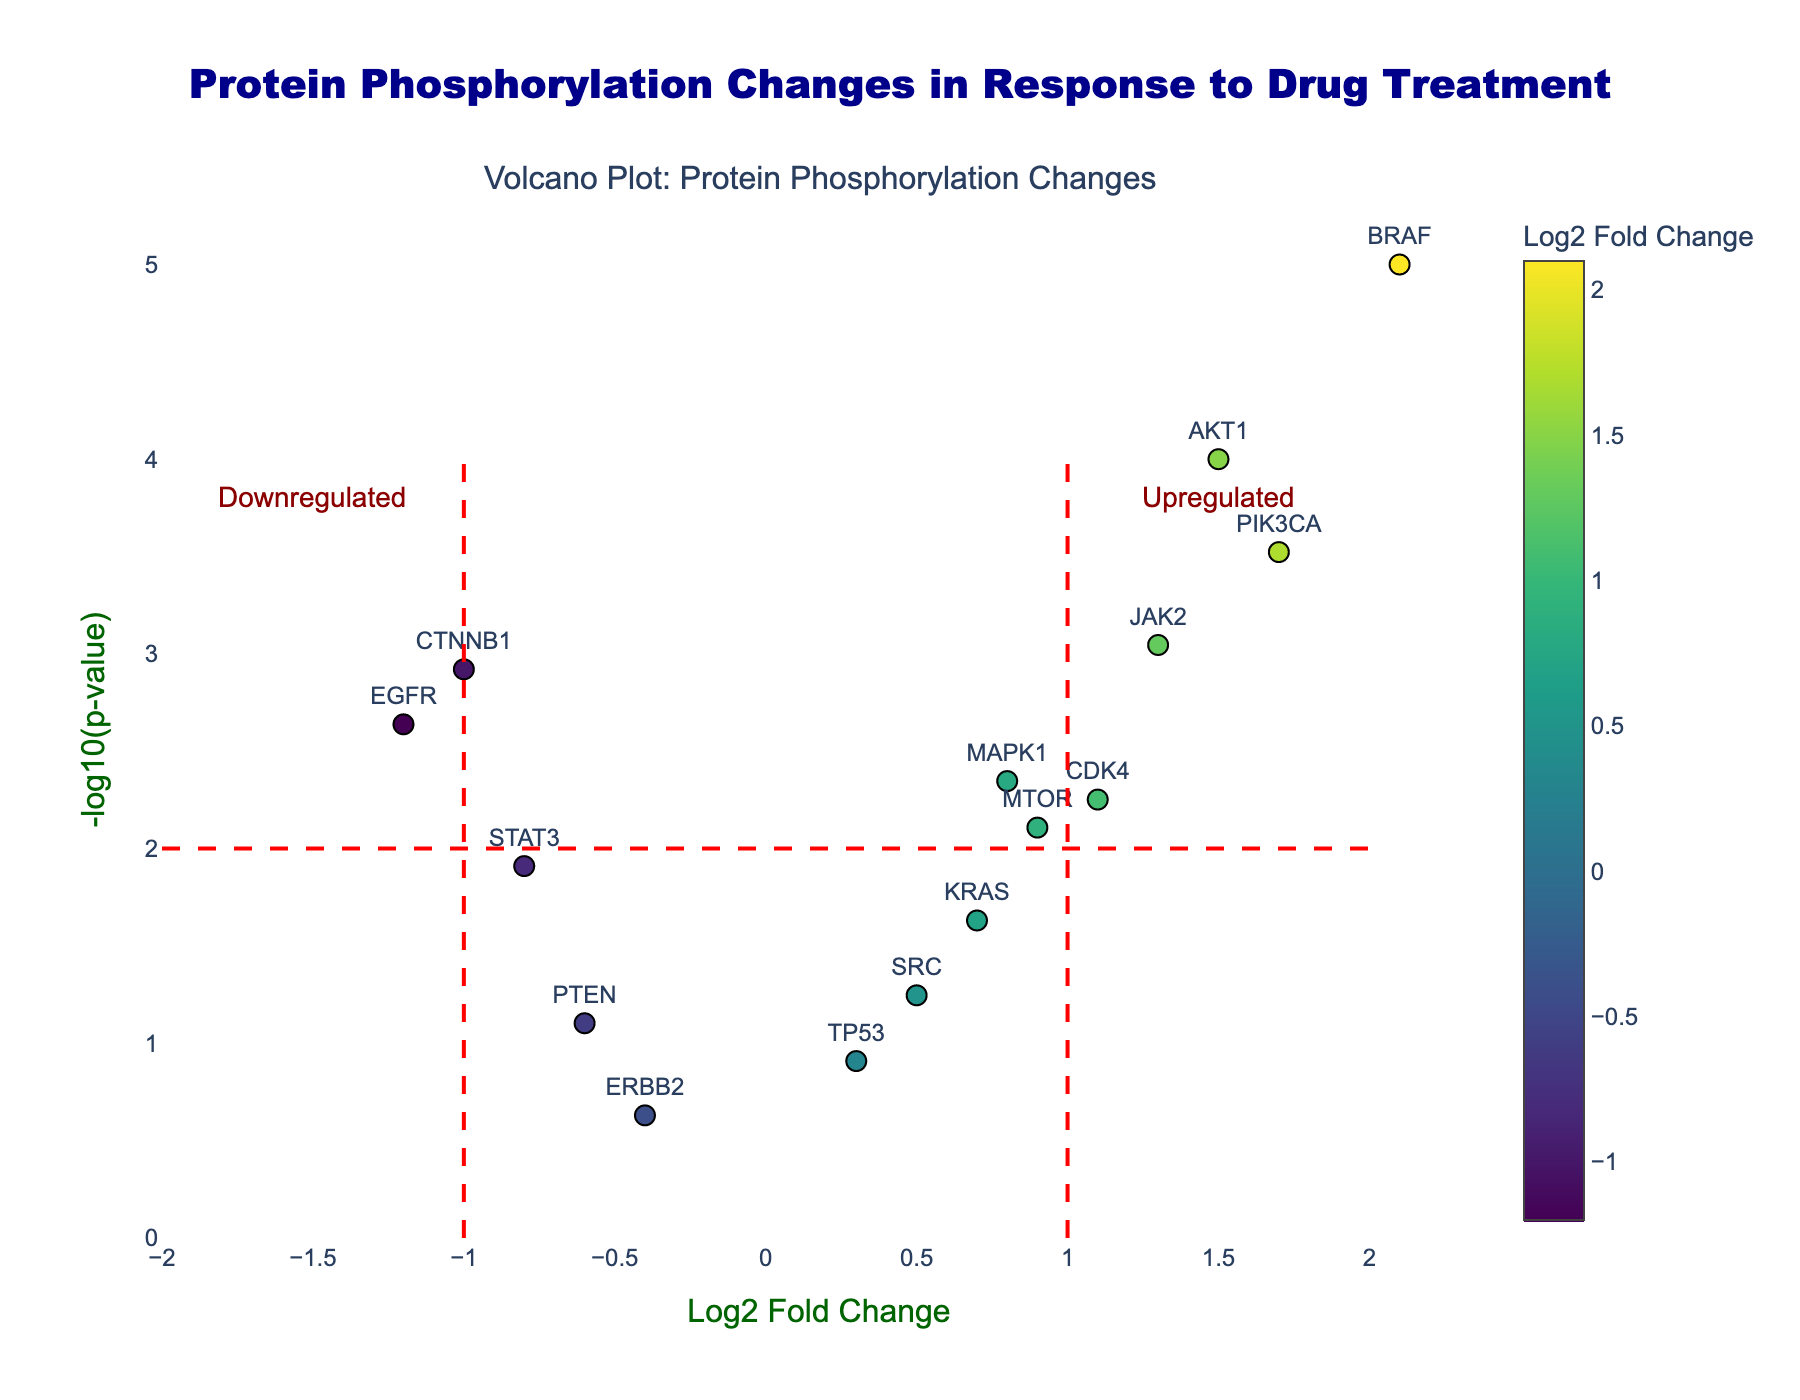What's the title of the figure? Look at the top center of the figure where the title is provided in a large font.
Answer: Protein Phosphorylation Changes in Response to Drug Treatment What is the highest log2 fold change observed in the figure? Find the data point with the maximum x-value (log2 fold change).
Answer: 2.1 Which protein has the smallest p-value and what does it indicate? Identify the data point with the highest y-value (-log10(p-value)) and check the corresponding protein. A smaller p-value indicates higher statistical significance.
Answer: BRAF How many proteins have a log2 fold change greater than 1? Count the number of data points located to the right of the red dashed line at x=1.
Answer: 5 Which protein is most significantly downregulated? Look for the lowest log2 fold change with a high -log10(p-value) (below the red line at x=-1).
Answer: EGFR What colors do the data points have? Observe the color scale used for the points, which ranges from green to purple.
Answer: Green to purple Which proteins are located outside the significance threshold lines? Identify the proteins that are placed beyond the dashed lines at x = -1, x = 1, and y = 2.
Answer: EGFR, MAPK1, AKT1, BRAF, MTOR, PIK3CA, CDK4, JAK2, CTNNB1 What is the combined log2 fold change of AKT1 and EGFR? Add the log2 fold change values for AKT1 and EGFR: 1.5 + (-1.2).
Answer: 0.3 Compare the significance of SRC and STAT3. Which one is more significant? Check the y-values (-log10(p-value)) for SRC and STAT3 and compare them. Higher value means more significant.
Answer: STAT3 What does the color of the EGFR data point indicate? Look at the color bar and match the color of the EGFR data point to its corresponding log2 fold change value.
Answer: Negative log2 fold change 